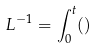Convert formula to latex. <formula><loc_0><loc_0><loc_500><loc_500>L ^ { - 1 } = \int _ { 0 } ^ { t } ( )</formula> 